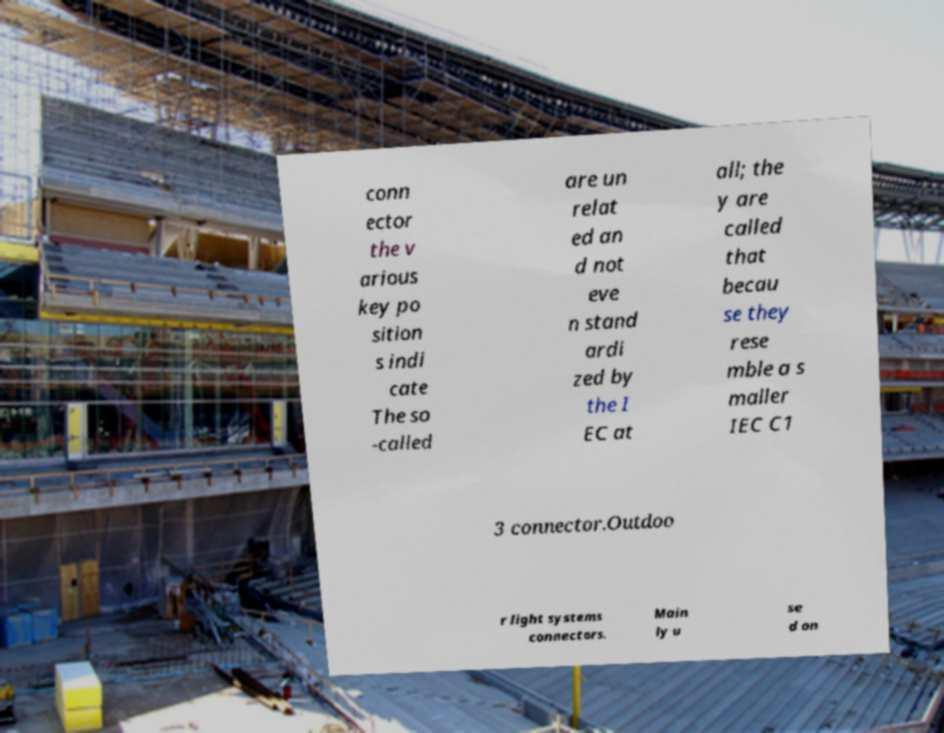What messages or text are displayed in this image? I need them in a readable, typed format. conn ector the v arious key po sition s indi cate The so -called are un relat ed an d not eve n stand ardi zed by the I EC at all; the y are called that becau se they rese mble a s maller IEC C1 3 connector.Outdoo r light systems connectors. Main ly u se d on 